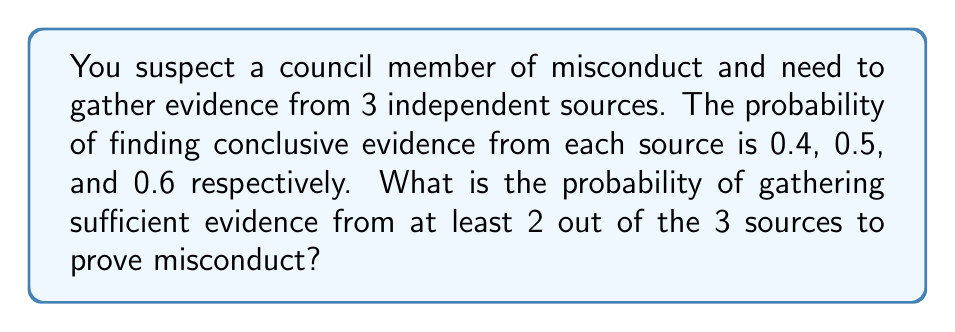What is the answer to this math problem? Let's approach this step-by-step:

1) First, we need to calculate the probability of success (finding evidence) for each source:
   Source 1: $p_1 = 0.4$
   Source 2: $p_2 = 0.5$
   Source 3: $p_3 = 0.6$

2) We want the probability of at least 2 successes out of 3 trials. This can happen in three ways:
   a) Success from sources 1 and 2, failure from 3
   b) Success from sources 1 and 3, failure from 2
   c) Success from sources 2 and 3, failure from 1
   d) Success from all three sources

3) Let's calculate each probability:
   a) $P(S_1 \cap S_2 \cap F_3) = 0.4 \times 0.5 \times (1-0.6) = 0.08$
   b) $P(S_1 \cap F_2 \cap S_3) = 0.4 \times (1-0.5) \times 0.6 = 0.12$
   c) $P(F_1 \cap S_2 \cap S_3) = (1-0.4) \times 0.5 \times 0.6 = 0.18$
   d) $P(S_1 \cap S_2 \cap S_3) = 0.4 \times 0.5 \times 0.6 = 0.12$

4) The total probability is the sum of these individual probabilities:
   $P(\text{at least 2 successes}) = 0.08 + 0.12 + 0.18 + 0.12 = 0.50$

Therefore, the probability of gathering sufficient evidence from at least 2 out of the 3 sources is 0.50 or 50%.
Answer: 0.50 